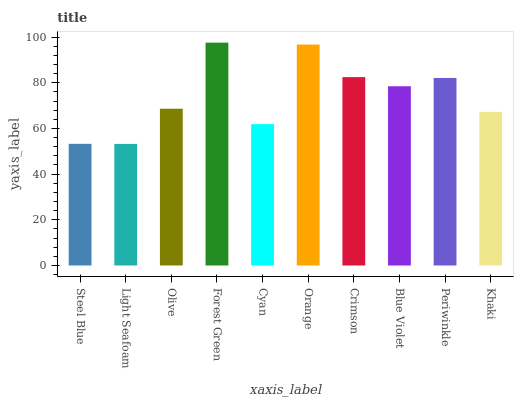Is Light Seafoam the minimum?
Answer yes or no. Yes. Is Forest Green the maximum?
Answer yes or no. Yes. Is Olive the minimum?
Answer yes or no. No. Is Olive the maximum?
Answer yes or no. No. Is Olive greater than Light Seafoam?
Answer yes or no. Yes. Is Light Seafoam less than Olive?
Answer yes or no. Yes. Is Light Seafoam greater than Olive?
Answer yes or no. No. Is Olive less than Light Seafoam?
Answer yes or no. No. Is Blue Violet the high median?
Answer yes or no. Yes. Is Olive the low median?
Answer yes or no. Yes. Is Forest Green the high median?
Answer yes or no. No. Is Periwinkle the low median?
Answer yes or no. No. 